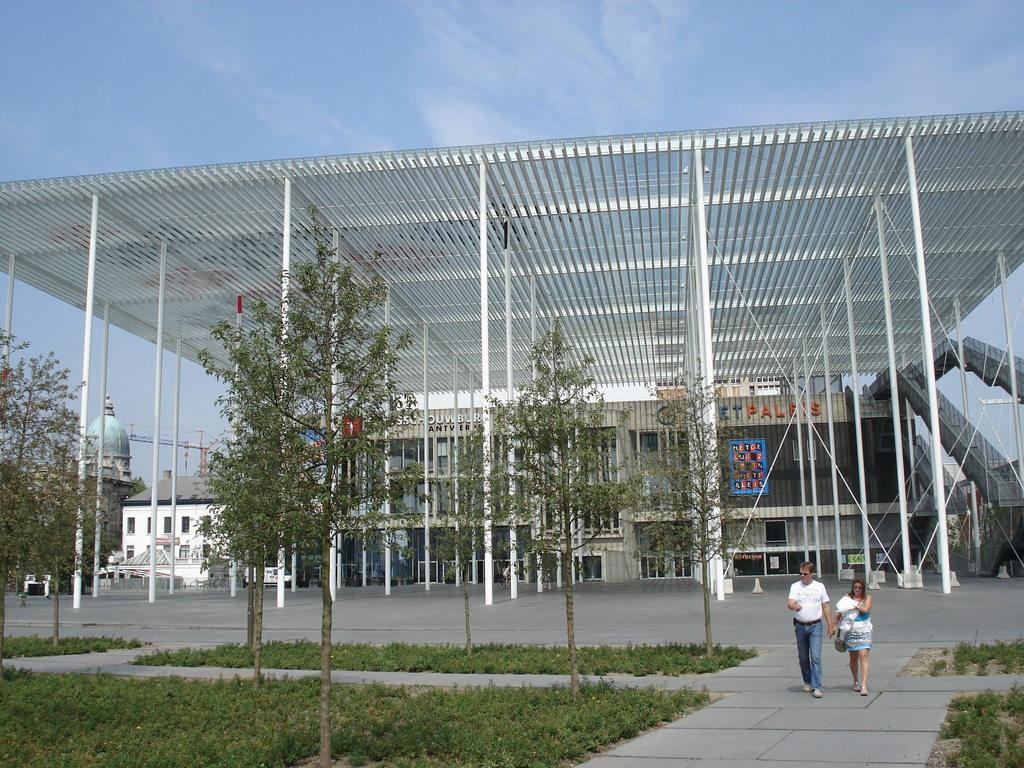In one or two sentences, can you explain what this image depicts? In this image there are two people walking on the platform, beside them there is grass and trees, behind them there are pillars and buildings. 